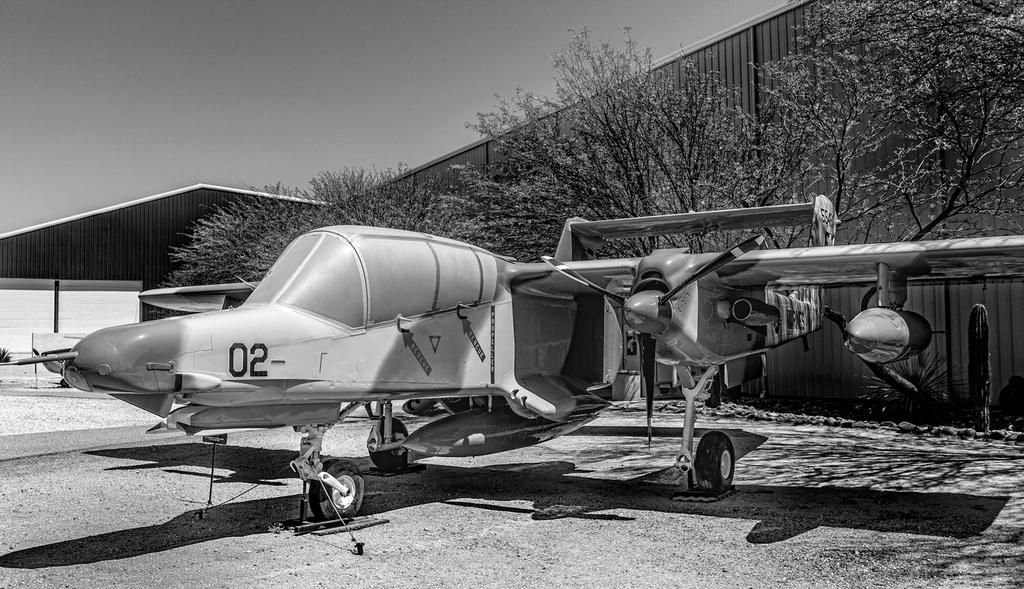<image>
Render a clear and concise summary of the photo. a plane with the number 02- on the front 